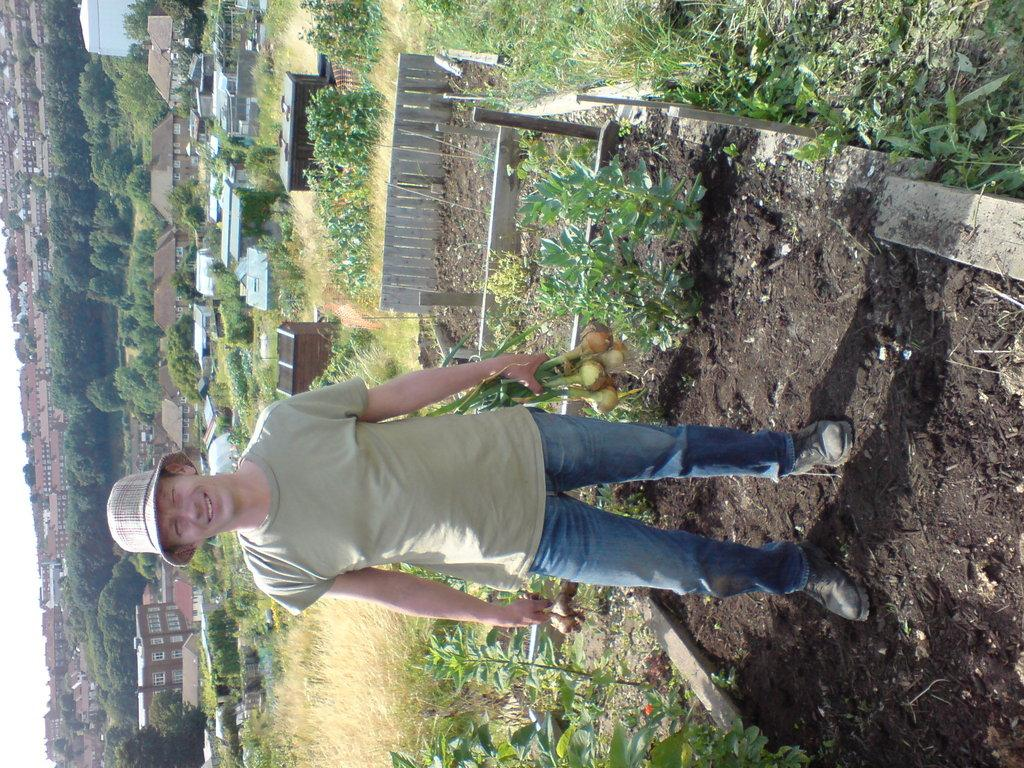What is the person in the image doing? The person is standing and smiling in the image. What is the person holding in the image? The person is holding vegetables. What can be seen in the background of the image? There are plants, houses, trees, and the sky visible in the background of the image. What type of dog can be seen pulling a plough in the image? There is no dog or plough present in the image. Can you describe the sink that is visible in the image? There is no sink present in the image. 